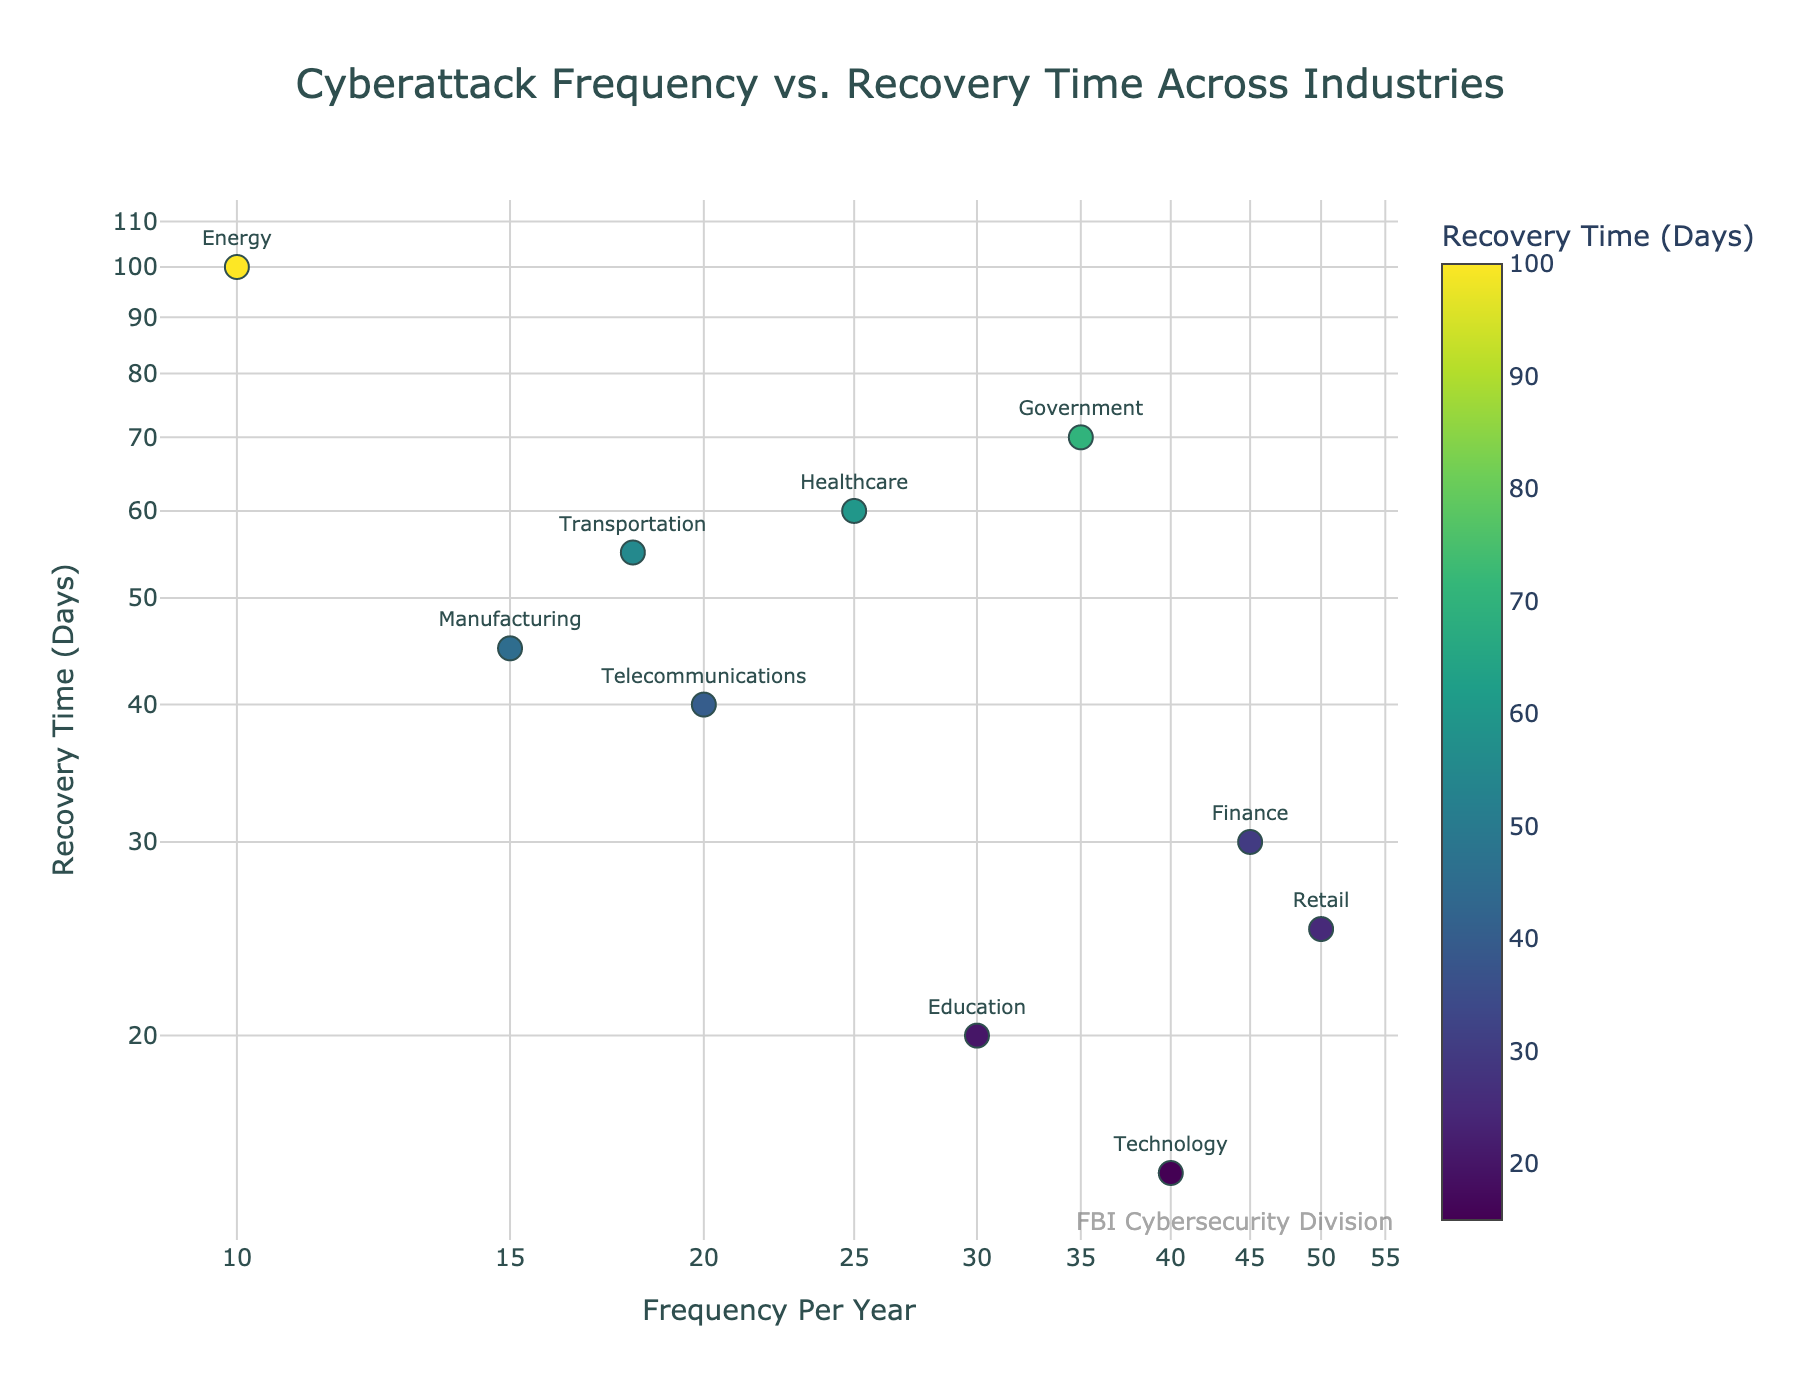What is the title of the figure? The title is displayed at the top center of the figure. It provides a summarized description of the plot.
Answer: Cyberattack Frequency vs. Recovery Time Across Industries How many data points are represented in the figure? Each industry provides one data point. Count the number of industries listed.
Answer: 10 Which industry has the highest frequency of cyberattacks per year? Look at the x-axis and identify the point farthest to the right. The associated industry label will be the answer.
Answer: Retail Which industry has the longest recovery time after a cyberattack? Look at the y-axis and identify the point highest on the axis. The associated industry label will be the answer.
Answer: Energy Compare the Technology and Healthcare industries based on their recovery times. Which one takes less time to recover? Locate the points for Technology and Healthcare on the y-axis and see which one is lower. Lower position means less recovery time.
Answer: Technology Among the data points, which two industries have the closest values in terms of cyberattack frequency? Identify two points on the x-axis that are closest to each other and note their respective industries.
Answer: Telecommunications and Healthcare What is the color corresponding to the industry with the lowest recovery time? Locate the industry with the lowest y-value and observe its color, which represents recovery time through the color scale.
Answer: Technology (color depends on the Viridis scale, typically yellowish-greenish) What is the average recovery time for Manufacturing and Transportation industries? Identify the recovery times for both industries (Manufacturing: 45 days, Transportation: 55 days). Calculate the average: (45 + 55) / 2 = 50.
Answer: 50 days Which industry has a frequency of cyberattacks closer to Technology, Finance or Government? Compare the x-axis positions of the points for Technology, Finance, and Government. Determine which point is closest to Technology.
Answer: Finance If we categorize industries based on recovery time as short (<30 days), medium (30-60 days), and long (>60 days), how many industries fall into each category? Classify each industry based on its y-axis value into the defined categories and count the number of industries in each category.
Short: Finance, Retail, Education, Technology.
Medium: Manufacturing, Telecommunications, Healthcare.
Long: Energy, Government, Transportation.
Answer: Short: 4, Medium: 3, Long: 3 